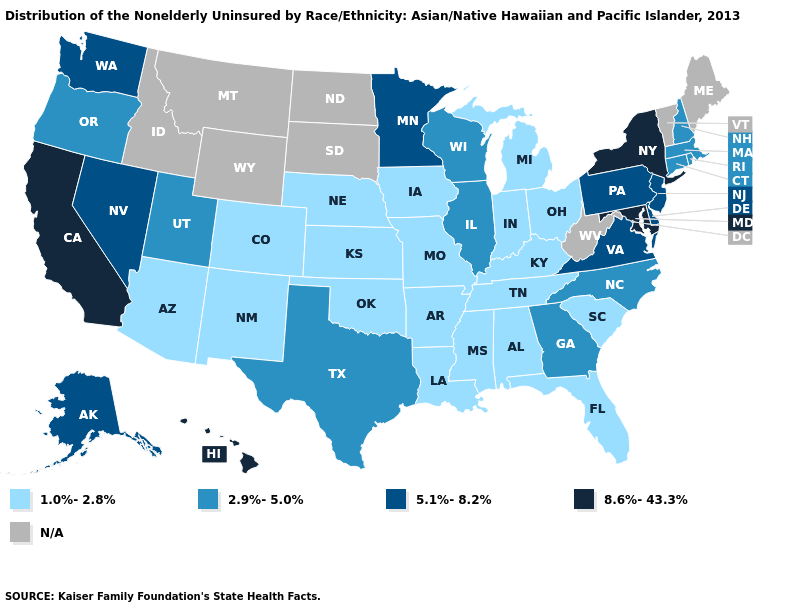What is the value of South Carolina?
Answer briefly. 1.0%-2.8%. Among the states that border Wisconsin , does Minnesota have the highest value?
Write a very short answer. Yes. Name the states that have a value in the range 1.0%-2.8%?
Concise answer only. Alabama, Arizona, Arkansas, Colorado, Florida, Indiana, Iowa, Kansas, Kentucky, Louisiana, Michigan, Mississippi, Missouri, Nebraska, New Mexico, Ohio, Oklahoma, South Carolina, Tennessee. Which states hav the highest value in the Northeast?
Quick response, please. New York. Name the states that have a value in the range 1.0%-2.8%?
Give a very brief answer. Alabama, Arizona, Arkansas, Colorado, Florida, Indiana, Iowa, Kansas, Kentucky, Louisiana, Michigan, Mississippi, Missouri, Nebraska, New Mexico, Ohio, Oklahoma, South Carolina, Tennessee. What is the value of Kansas?
Be succinct. 1.0%-2.8%. What is the value of Hawaii?
Short answer required. 8.6%-43.3%. Which states have the lowest value in the MidWest?
Keep it brief. Indiana, Iowa, Kansas, Michigan, Missouri, Nebraska, Ohio. Among the states that border Oregon , which have the lowest value?
Be succinct. Nevada, Washington. Name the states that have a value in the range 2.9%-5.0%?
Concise answer only. Connecticut, Georgia, Illinois, Massachusetts, New Hampshire, North Carolina, Oregon, Rhode Island, Texas, Utah, Wisconsin. What is the lowest value in states that border Kentucky?
Give a very brief answer. 1.0%-2.8%. Name the states that have a value in the range 2.9%-5.0%?
Quick response, please. Connecticut, Georgia, Illinois, Massachusetts, New Hampshire, North Carolina, Oregon, Rhode Island, Texas, Utah, Wisconsin. Among the states that border Oklahoma , does Kansas have the highest value?
Answer briefly. No. Name the states that have a value in the range N/A?
Concise answer only. Idaho, Maine, Montana, North Dakota, South Dakota, Vermont, West Virginia, Wyoming. Name the states that have a value in the range 2.9%-5.0%?
Give a very brief answer. Connecticut, Georgia, Illinois, Massachusetts, New Hampshire, North Carolina, Oregon, Rhode Island, Texas, Utah, Wisconsin. 